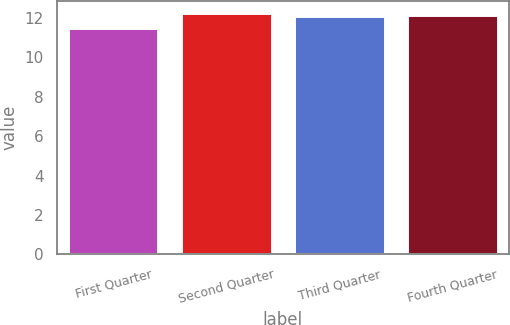Convert chart. <chart><loc_0><loc_0><loc_500><loc_500><bar_chart><fcel>First Quarter<fcel>Second Quarter<fcel>Third Quarter<fcel>Fourth Quarter<nl><fcel>11.48<fcel>12.25<fcel>12.07<fcel>12.15<nl></chart> 